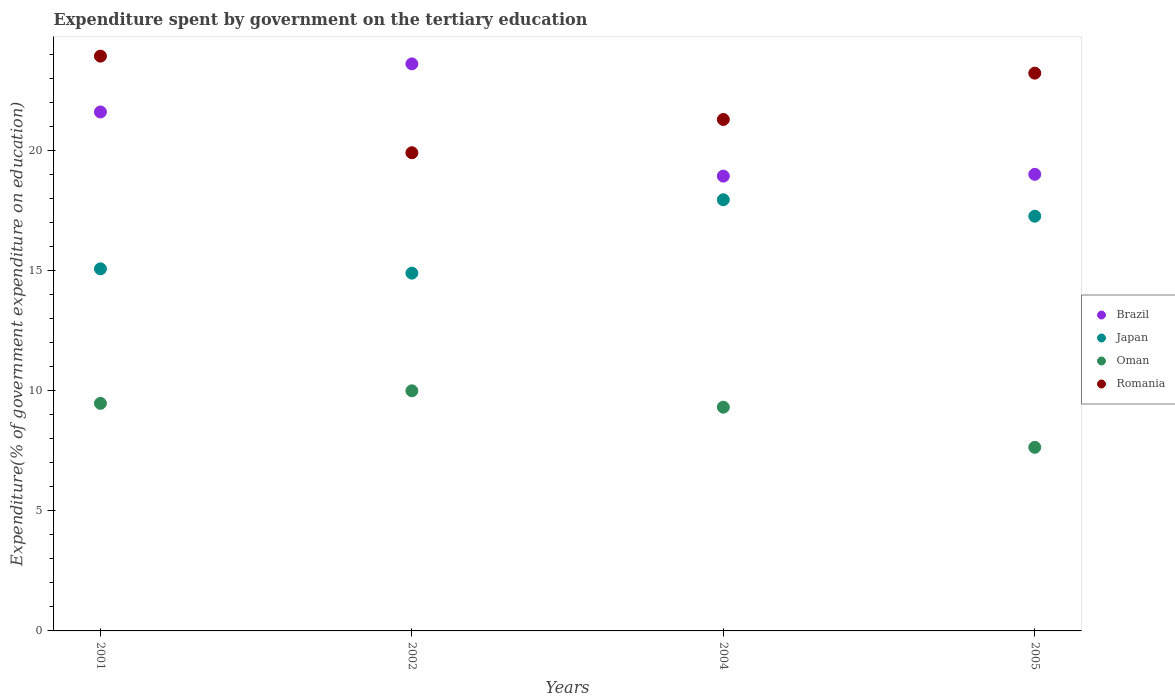How many different coloured dotlines are there?
Your answer should be very brief. 4. Is the number of dotlines equal to the number of legend labels?
Keep it short and to the point. Yes. What is the expenditure spent by government on the tertiary education in Oman in 2002?
Your response must be concise. 9.99. Across all years, what is the maximum expenditure spent by government on the tertiary education in Japan?
Your response must be concise. 17.94. Across all years, what is the minimum expenditure spent by government on the tertiary education in Brazil?
Provide a succinct answer. 18.92. What is the total expenditure spent by government on the tertiary education in Japan in the graph?
Offer a very short reply. 65.14. What is the difference between the expenditure spent by government on the tertiary education in Oman in 2001 and that in 2002?
Your answer should be very brief. -0.52. What is the difference between the expenditure spent by government on the tertiary education in Brazil in 2005 and the expenditure spent by government on the tertiary education in Japan in 2001?
Your answer should be compact. 3.93. What is the average expenditure spent by government on the tertiary education in Oman per year?
Offer a very short reply. 9.1. In the year 2002, what is the difference between the expenditure spent by government on the tertiary education in Brazil and expenditure spent by government on the tertiary education in Romania?
Provide a succinct answer. 3.7. What is the ratio of the expenditure spent by government on the tertiary education in Oman in 2002 to that in 2005?
Provide a succinct answer. 1.31. Is the expenditure spent by government on the tertiary education in Japan in 2002 less than that in 2004?
Your answer should be compact. Yes. What is the difference between the highest and the second highest expenditure spent by government on the tertiary education in Brazil?
Your answer should be compact. 2. What is the difference between the highest and the lowest expenditure spent by government on the tertiary education in Romania?
Your response must be concise. 4.02. Is the sum of the expenditure spent by government on the tertiary education in Oman in 2001 and 2005 greater than the maximum expenditure spent by government on the tertiary education in Brazil across all years?
Ensure brevity in your answer.  No. Is it the case that in every year, the sum of the expenditure spent by government on the tertiary education in Oman and expenditure spent by government on the tertiary education in Brazil  is greater than the sum of expenditure spent by government on the tertiary education in Japan and expenditure spent by government on the tertiary education in Romania?
Keep it short and to the point. No. Is the expenditure spent by government on the tertiary education in Japan strictly greater than the expenditure spent by government on the tertiary education in Romania over the years?
Your response must be concise. No. How many years are there in the graph?
Offer a terse response. 4. Does the graph contain grids?
Make the answer very short. No. Where does the legend appear in the graph?
Offer a very short reply. Center right. How many legend labels are there?
Give a very brief answer. 4. How are the legend labels stacked?
Give a very brief answer. Vertical. What is the title of the graph?
Your answer should be compact. Expenditure spent by government on the tertiary education. Does "Central Europe" appear as one of the legend labels in the graph?
Your response must be concise. No. What is the label or title of the X-axis?
Ensure brevity in your answer.  Years. What is the label or title of the Y-axis?
Your answer should be compact. Expenditure(% of government expenditure on education). What is the Expenditure(% of government expenditure on education) of Brazil in 2001?
Offer a terse response. 21.59. What is the Expenditure(% of government expenditure on education) of Japan in 2001?
Offer a terse response. 15.06. What is the Expenditure(% of government expenditure on education) of Oman in 2001?
Your answer should be compact. 9.47. What is the Expenditure(% of government expenditure on education) of Romania in 2001?
Provide a short and direct response. 23.91. What is the Expenditure(% of government expenditure on education) of Brazil in 2002?
Your answer should be compact. 23.59. What is the Expenditure(% of government expenditure on education) of Japan in 2002?
Provide a short and direct response. 14.88. What is the Expenditure(% of government expenditure on education) of Oman in 2002?
Give a very brief answer. 9.99. What is the Expenditure(% of government expenditure on education) of Romania in 2002?
Offer a very short reply. 19.89. What is the Expenditure(% of government expenditure on education) of Brazil in 2004?
Offer a very short reply. 18.92. What is the Expenditure(% of government expenditure on education) of Japan in 2004?
Offer a terse response. 17.94. What is the Expenditure(% of government expenditure on education) in Oman in 2004?
Make the answer very short. 9.31. What is the Expenditure(% of government expenditure on education) of Romania in 2004?
Your answer should be compact. 21.28. What is the Expenditure(% of government expenditure on education) in Brazil in 2005?
Provide a short and direct response. 19. What is the Expenditure(% of government expenditure on education) in Japan in 2005?
Keep it short and to the point. 17.25. What is the Expenditure(% of government expenditure on education) of Oman in 2005?
Give a very brief answer. 7.64. What is the Expenditure(% of government expenditure on education) in Romania in 2005?
Keep it short and to the point. 23.2. Across all years, what is the maximum Expenditure(% of government expenditure on education) in Brazil?
Your response must be concise. 23.59. Across all years, what is the maximum Expenditure(% of government expenditure on education) of Japan?
Your answer should be compact. 17.94. Across all years, what is the maximum Expenditure(% of government expenditure on education) in Oman?
Offer a terse response. 9.99. Across all years, what is the maximum Expenditure(% of government expenditure on education) in Romania?
Provide a short and direct response. 23.91. Across all years, what is the minimum Expenditure(% of government expenditure on education) of Brazil?
Provide a succinct answer. 18.92. Across all years, what is the minimum Expenditure(% of government expenditure on education) in Japan?
Your answer should be very brief. 14.88. Across all years, what is the minimum Expenditure(% of government expenditure on education) in Oman?
Give a very brief answer. 7.64. Across all years, what is the minimum Expenditure(% of government expenditure on education) of Romania?
Your response must be concise. 19.89. What is the total Expenditure(% of government expenditure on education) in Brazil in the graph?
Make the answer very short. 83.09. What is the total Expenditure(% of government expenditure on education) in Japan in the graph?
Give a very brief answer. 65.14. What is the total Expenditure(% of government expenditure on education) of Oman in the graph?
Offer a very short reply. 36.4. What is the total Expenditure(% of government expenditure on education) in Romania in the graph?
Provide a succinct answer. 88.28. What is the difference between the Expenditure(% of government expenditure on education) in Brazil in 2001 and that in 2002?
Keep it short and to the point. -2. What is the difference between the Expenditure(% of government expenditure on education) in Japan in 2001 and that in 2002?
Give a very brief answer. 0.18. What is the difference between the Expenditure(% of government expenditure on education) in Oman in 2001 and that in 2002?
Your answer should be very brief. -0.52. What is the difference between the Expenditure(% of government expenditure on education) of Romania in 2001 and that in 2002?
Provide a succinct answer. 4.02. What is the difference between the Expenditure(% of government expenditure on education) in Brazil in 2001 and that in 2004?
Offer a very short reply. 2.67. What is the difference between the Expenditure(% of government expenditure on education) in Japan in 2001 and that in 2004?
Ensure brevity in your answer.  -2.87. What is the difference between the Expenditure(% of government expenditure on education) in Oman in 2001 and that in 2004?
Provide a short and direct response. 0.16. What is the difference between the Expenditure(% of government expenditure on education) of Romania in 2001 and that in 2004?
Offer a very short reply. 2.64. What is the difference between the Expenditure(% of government expenditure on education) of Brazil in 2001 and that in 2005?
Ensure brevity in your answer.  2.59. What is the difference between the Expenditure(% of government expenditure on education) in Japan in 2001 and that in 2005?
Keep it short and to the point. -2.19. What is the difference between the Expenditure(% of government expenditure on education) in Oman in 2001 and that in 2005?
Provide a succinct answer. 1.83. What is the difference between the Expenditure(% of government expenditure on education) of Romania in 2001 and that in 2005?
Keep it short and to the point. 0.71. What is the difference between the Expenditure(% of government expenditure on education) in Brazil in 2002 and that in 2004?
Provide a short and direct response. 4.67. What is the difference between the Expenditure(% of government expenditure on education) in Japan in 2002 and that in 2004?
Your answer should be very brief. -3.05. What is the difference between the Expenditure(% of government expenditure on education) in Oman in 2002 and that in 2004?
Your answer should be compact. 0.68. What is the difference between the Expenditure(% of government expenditure on education) in Romania in 2002 and that in 2004?
Keep it short and to the point. -1.38. What is the difference between the Expenditure(% of government expenditure on education) in Brazil in 2002 and that in 2005?
Your answer should be compact. 4.59. What is the difference between the Expenditure(% of government expenditure on education) of Japan in 2002 and that in 2005?
Provide a short and direct response. -2.37. What is the difference between the Expenditure(% of government expenditure on education) in Oman in 2002 and that in 2005?
Your answer should be very brief. 2.35. What is the difference between the Expenditure(% of government expenditure on education) in Romania in 2002 and that in 2005?
Your response must be concise. -3.31. What is the difference between the Expenditure(% of government expenditure on education) of Brazil in 2004 and that in 2005?
Provide a succinct answer. -0.07. What is the difference between the Expenditure(% of government expenditure on education) in Japan in 2004 and that in 2005?
Provide a succinct answer. 0.68. What is the difference between the Expenditure(% of government expenditure on education) in Oman in 2004 and that in 2005?
Your answer should be compact. 1.67. What is the difference between the Expenditure(% of government expenditure on education) in Romania in 2004 and that in 2005?
Give a very brief answer. -1.93. What is the difference between the Expenditure(% of government expenditure on education) in Brazil in 2001 and the Expenditure(% of government expenditure on education) in Japan in 2002?
Keep it short and to the point. 6.71. What is the difference between the Expenditure(% of government expenditure on education) of Brazil in 2001 and the Expenditure(% of government expenditure on education) of Oman in 2002?
Provide a succinct answer. 11.6. What is the difference between the Expenditure(% of government expenditure on education) in Brazil in 2001 and the Expenditure(% of government expenditure on education) in Romania in 2002?
Your answer should be compact. 1.7. What is the difference between the Expenditure(% of government expenditure on education) of Japan in 2001 and the Expenditure(% of government expenditure on education) of Oman in 2002?
Offer a very short reply. 5.07. What is the difference between the Expenditure(% of government expenditure on education) of Japan in 2001 and the Expenditure(% of government expenditure on education) of Romania in 2002?
Ensure brevity in your answer.  -4.83. What is the difference between the Expenditure(% of government expenditure on education) in Oman in 2001 and the Expenditure(% of government expenditure on education) in Romania in 2002?
Your response must be concise. -10.43. What is the difference between the Expenditure(% of government expenditure on education) in Brazil in 2001 and the Expenditure(% of government expenditure on education) in Japan in 2004?
Provide a succinct answer. 3.65. What is the difference between the Expenditure(% of government expenditure on education) of Brazil in 2001 and the Expenditure(% of government expenditure on education) of Oman in 2004?
Provide a short and direct response. 12.28. What is the difference between the Expenditure(% of government expenditure on education) in Brazil in 2001 and the Expenditure(% of government expenditure on education) in Romania in 2004?
Ensure brevity in your answer.  0.31. What is the difference between the Expenditure(% of government expenditure on education) of Japan in 2001 and the Expenditure(% of government expenditure on education) of Oman in 2004?
Provide a short and direct response. 5.76. What is the difference between the Expenditure(% of government expenditure on education) of Japan in 2001 and the Expenditure(% of government expenditure on education) of Romania in 2004?
Your answer should be very brief. -6.21. What is the difference between the Expenditure(% of government expenditure on education) in Oman in 2001 and the Expenditure(% of government expenditure on education) in Romania in 2004?
Ensure brevity in your answer.  -11.81. What is the difference between the Expenditure(% of government expenditure on education) in Brazil in 2001 and the Expenditure(% of government expenditure on education) in Japan in 2005?
Give a very brief answer. 4.34. What is the difference between the Expenditure(% of government expenditure on education) in Brazil in 2001 and the Expenditure(% of government expenditure on education) in Oman in 2005?
Your answer should be compact. 13.95. What is the difference between the Expenditure(% of government expenditure on education) in Brazil in 2001 and the Expenditure(% of government expenditure on education) in Romania in 2005?
Provide a short and direct response. -1.62. What is the difference between the Expenditure(% of government expenditure on education) of Japan in 2001 and the Expenditure(% of government expenditure on education) of Oman in 2005?
Offer a terse response. 7.43. What is the difference between the Expenditure(% of government expenditure on education) in Japan in 2001 and the Expenditure(% of government expenditure on education) in Romania in 2005?
Your answer should be very brief. -8.14. What is the difference between the Expenditure(% of government expenditure on education) in Oman in 2001 and the Expenditure(% of government expenditure on education) in Romania in 2005?
Your answer should be very brief. -13.74. What is the difference between the Expenditure(% of government expenditure on education) of Brazil in 2002 and the Expenditure(% of government expenditure on education) of Japan in 2004?
Your answer should be compact. 5.65. What is the difference between the Expenditure(% of government expenditure on education) in Brazil in 2002 and the Expenditure(% of government expenditure on education) in Oman in 2004?
Give a very brief answer. 14.28. What is the difference between the Expenditure(% of government expenditure on education) in Brazil in 2002 and the Expenditure(% of government expenditure on education) in Romania in 2004?
Give a very brief answer. 2.31. What is the difference between the Expenditure(% of government expenditure on education) in Japan in 2002 and the Expenditure(% of government expenditure on education) in Oman in 2004?
Ensure brevity in your answer.  5.58. What is the difference between the Expenditure(% of government expenditure on education) in Japan in 2002 and the Expenditure(% of government expenditure on education) in Romania in 2004?
Offer a terse response. -6.39. What is the difference between the Expenditure(% of government expenditure on education) in Oman in 2002 and the Expenditure(% of government expenditure on education) in Romania in 2004?
Offer a very short reply. -11.29. What is the difference between the Expenditure(% of government expenditure on education) of Brazil in 2002 and the Expenditure(% of government expenditure on education) of Japan in 2005?
Your answer should be compact. 6.34. What is the difference between the Expenditure(% of government expenditure on education) in Brazil in 2002 and the Expenditure(% of government expenditure on education) in Oman in 2005?
Your answer should be very brief. 15.95. What is the difference between the Expenditure(% of government expenditure on education) in Brazil in 2002 and the Expenditure(% of government expenditure on education) in Romania in 2005?
Ensure brevity in your answer.  0.39. What is the difference between the Expenditure(% of government expenditure on education) in Japan in 2002 and the Expenditure(% of government expenditure on education) in Oman in 2005?
Offer a very short reply. 7.25. What is the difference between the Expenditure(% of government expenditure on education) of Japan in 2002 and the Expenditure(% of government expenditure on education) of Romania in 2005?
Provide a short and direct response. -8.32. What is the difference between the Expenditure(% of government expenditure on education) in Oman in 2002 and the Expenditure(% of government expenditure on education) in Romania in 2005?
Give a very brief answer. -13.22. What is the difference between the Expenditure(% of government expenditure on education) of Brazil in 2004 and the Expenditure(% of government expenditure on education) of Japan in 2005?
Your answer should be compact. 1.67. What is the difference between the Expenditure(% of government expenditure on education) of Brazil in 2004 and the Expenditure(% of government expenditure on education) of Oman in 2005?
Your answer should be compact. 11.28. What is the difference between the Expenditure(% of government expenditure on education) in Brazil in 2004 and the Expenditure(% of government expenditure on education) in Romania in 2005?
Keep it short and to the point. -4.28. What is the difference between the Expenditure(% of government expenditure on education) of Japan in 2004 and the Expenditure(% of government expenditure on education) of Oman in 2005?
Offer a terse response. 10.3. What is the difference between the Expenditure(% of government expenditure on education) of Japan in 2004 and the Expenditure(% of government expenditure on education) of Romania in 2005?
Your answer should be very brief. -5.27. What is the difference between the Expenditure(% of government expenditure on education) in Oman in 2004 and the Expenditure(% of government expenditure on education) in Romania in 2005?
Provide a succinct answer. -13.9. What is the average Expenditure(% of government expenditure on education) in Brazil per year?
Provide a succinct answer. 20.77. What is the average Expenditure(% of government expenditure on education) of Japan per year?
Your response must be concise. 16.28. What is the average Expenditure(% of government expenditure on education) in Oman per year?
Make the answer very short. 9.1. What is the average Expenditure(% of government expenditure on education) of Romania per year?
Your response must be concise. 22.07. In the year 2001, what is the difference between the Expenditure(% of government expenditure on education) in Brazil and Expenditure(% of government expenditure on education) in Japan?
Your response must be concise. 6.53. In the year 2001, what is the difference between the Expenditure(% of government expenditure on education) in Brazil and Expenditure(% of government expenditure on education) in Oman?
Your response must be concise. 12.12. In the year 2001, what is the difference between the Expenditure(% of government expenditure on education) of Brazil and Expenditure(% of government expenditure on education) of Romania?
Give a very brief answer. -2.32. In the year 2001, what is the difference between the Expenditure(% of government expenditure on education) in Japan and Expenditure(% of government expenditure on education) in Oman?
Your answer should be compact. 5.6. In the year 2001, what is the difference between the Expenditure(% of government expenditure on education) in Japan and Expenditure(% of government expenditure on education) in Romania?
Your answer should be very brief. -8.85. In the year 2001, what is the difference between the Expenditure(% of government expenditure on education) in Oman and Expenditure(% of government expenditure on education) in Romania?
Your response must be concise. -14.44. In the year 2002, what is the difference between the Expenditure(% of government expenditure on education) of Brazil and Expenditure(% of government expenditure on education) of Japan?
Give a very brief answer. 8.71. In the year 2002, what is the difference between the Expenditure(% of government expenditure on education) in Brazil and Expenditure(% of government expenditure on education) in Oman?
Provide a succinct answer. 13.6. In the year 2002, what is the difference between the Expenditure(% of government expenditure on education) in Brazil and Expenditure(% of government expenditure on education) in Romania?
Keep it short and to the point. 3.7. In the year 2002, what is the difference between the Expenditure(% of government expenditure on education) of Japan and Expenditure(% of government expenditure on education) of Oman?
Offer a terse response. 4.9. In the year 2002, what is the difference between the Expenditure(% of government expenditure on education) in Japan and Expenditure(% of government expenditure on education) in Romania?
Make the answer very short. -5.01. In the year 2002, what is the difference between the Expenditure(% of government expenditure on education) in Oman and Expenditure(% of government expenditure on education) in Romania?
Offer a terse response. -9.9. In the year 2004, what is the difference between the Expenditure(% of government expenditure on education) of Brazil and Expenditure(% of government expenditure on education) of Japan?
Keep it short and to the point. 0.98. In the year 2004, what is the difference between the Expenditure(% of government expenditure on education) of Brazil and Expenditure(% of government expenditure on education) of Oman?
Give a very brief answer. 9.61. In the year 2004, what is the difference between the Expenditure(% of government expenditure on education) in Brazil and Expenditure(% of government expenditure on education) in Romania?
Your answer should be compact. -2.36. In the year 2004, what is the difference between the Expenditure(% of government expenditure on education) of Japan and Expenditure(% of government expenditure on education) of Oman?
Keep it short and to the point. 8.63. In the year 2004, what is the difference between the Expenditure(% of government expenditure on education) in Japan and Expenditure(% of government expenditure on education) in Romania?
Ensure brevity in your answer.  -3.34. In the year 2004, what is the difference between the Expenditure(% of government expenditure on education) in Oman and Expenditure(% of government expenditure on education) in Romania?
Your answer should be very brief. -11.97. In the year 2005, what is the difference between the Expenditure(% of government expenditure on education) of Brazil and Expenditure(% of government expenditure on education) of Japan?
Make the answer very short. 1.74. In the year 2005, what is the difference between the Expenditure(% of government expenditure on education) in Brazil and Expenditure(% of government expenditure on education) in Oman?
Offer a terse response. 11.36. In the year 2005, what is the difference between the Expenditure(% of government expenditure on education) in Brazil and Expenditure(% of government expenditure on education) in Romania?
Your response must be concise. -4.21. In the year 2005, what is the difference between the Expenditure(% of government expenditure on education) in Japan and Expenditure(% of government expenditure on education) in Oman?
Offer a terse response. 9.61. In the year 2005, what is the difference between the Expenditure(% of government expenditure on education) in Japan and Expenditure(% of government expenditure on education) in Romania?
Your response must be concise. -5.95. In the year 2005, what is the difference between the Expenditure(% of government expenditure on education) in Oman and Expenditure(% of government expenditure on education) in Romania?
Ensure brevity in your answer.  -15.57. What is the ratio of the Expenditure(% of government expenditure on education) in Brazil in 2001 to that in 2002?
Ensure brevity in your answer.  0.92. What is the ratio of the Expenditure(% of government expenditure on education) of Oman in 2001 to that in 2002?
Provide a succinct answer. 0.95. What is the ratio of the Expenditure(% of government expenditure on education) in Romania in 2001 to that in 2002?
Your answer should be very brief. 1.2. What is the ratio of the Expenditure(% of government expenditure on education) of Brazil in 2001 to that in 2004?
Provide a succinct answer. 1.14. What is the ratio of the Expenditure(% of government expenditure on education) in Japan in 2001 to that in 2004?
Ensure brevity in your answer.  0.84. What is the ratio of the Expenditure(% of government expenditure on education) of Oman in 2001 to that in 2004?
Provide a short and direct response. 1.02. What is the ratio of the Expenditure(% of government expenditure on education) in Romania in 2001 to that in 2004?
Your answer should be very brief. 1.12. What is the ratio of the Expenditure(% of government expenditure on education) of Brazil in 2001 to that in 2005?
Provide a short and direct response. 1.14. What is the ratio of the Expenditure(% of government expenditure on education) in Japan in 2001 to that in 2005?
Make the answer very short. 0.87. What is the ratio of the Expenditure(% of government expenditure on education) of Oman in 2001 to that in 2005?
Your answer should be very brief. 1.24. What is the ratio of the Expenditure(% of government expenditure on education) in Romania in 2001 to that in 2005?
Ensure brevity in your answer.  1.03. What is the ratio of the Expenditure(% of government expenditure on education) in Brazil in 2002 to that in 2004?
Offer a very short reply. 1.25. What is the ratio of the Expenditure(% of government expenditure on education) in Japan in 2002 to that in 2004?
Your answer should be compact. 0.83. What is the ratio of the Expenditure(% of government expenditure on education) of Oman in 2002 to that in 2004?
Make the answer very short. 1.07. What is the ratio of the Expenditure(% of government expenditure on education) of Romania in 2002 to that in 2004?
Keep it short and to the point. 0.94. What is the ratio of the Expenditure(% of government expenditure on education) in Brazil in 2002 to that in 2005?
Provide a succinct answer. 1.24. What is the ratio of the Expenditure(% of government expenditure on education) in Japan in 2002 to that in 2005?
Give a very brief answer. 0.86. What is the ratio of the Expenditure(% of government expenditure on education) of Oman in 2002 to that in 2005?
Provide a short and direct response. 1.31. What is the ratio of the Expenditure(% of government expenditure on education) of Romania in 2002 to that in 2005?
Provide a short and direct response. 0.86. What is the ratio of the Expenditure(% of government expenditure on education) of Japan in 2004 to that in 2005?
Ensure brevity in your answer.  1.04. What is the ratio of the Expenditure(% of government expenditure on education) in Oman in 2004 to that in 2005?
Ensure brevity in your answer.  1.22. What is the ratio of the Expenditure(% of government expenditure on education) in Romania in 2004 to that in 2005?
Offer a very short reply. 0.92. What is the difference between the highest and the second highest Expenditure(% of government expenditure on education) of Brazil?
Give a very brief answer. 2. What is the difference between the highest and the second highest Expenditure(% of government expenditure on education) in Japan?
Ensure brevity in your answer.  0.68. What is the difference between the highest and the second highest Expenditure(% of government expenditure on education) of Oman?
Provide a succinct answer. 0.52. What is the difference between the highest and the second highest Expenditure(% of government expenditure on education) in Romania?
Give a very brief answer. 0.71. What is the difference between the highest and the lowest Expenditure(% of government expenditure on education) of Brazil?
Offer a terse response. 4.67. What is the difference between the highest and the lowest Expenditure(% of government expenditure on education) in Japan?
Keep it short and to the point. 3.05. What is the difference between the highest and the lowest Expenditure(% of government expenditure on education) in Oman?
Provide a short and direct response. 2.35. What is the difference between the highest and the lowest Expenditure(% of government expenditure on education) in Romania?
Give a very brief answer. 4.02. 